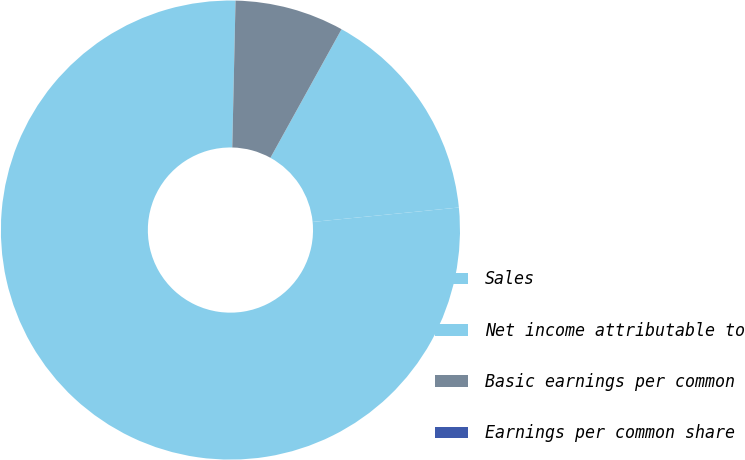Convert chart to OTSL. <chart><loc_0><loc_0><loc_500><loc_500><pie_chart><fcel>Sales<fcel>Net income attributable to<fcel>Basic earnings per common<fcel>Earnings per common share<nl><fcel>76.92%<fcel>15.39%<fcel>7.69%<fcel>0.0%<nl></chart> 